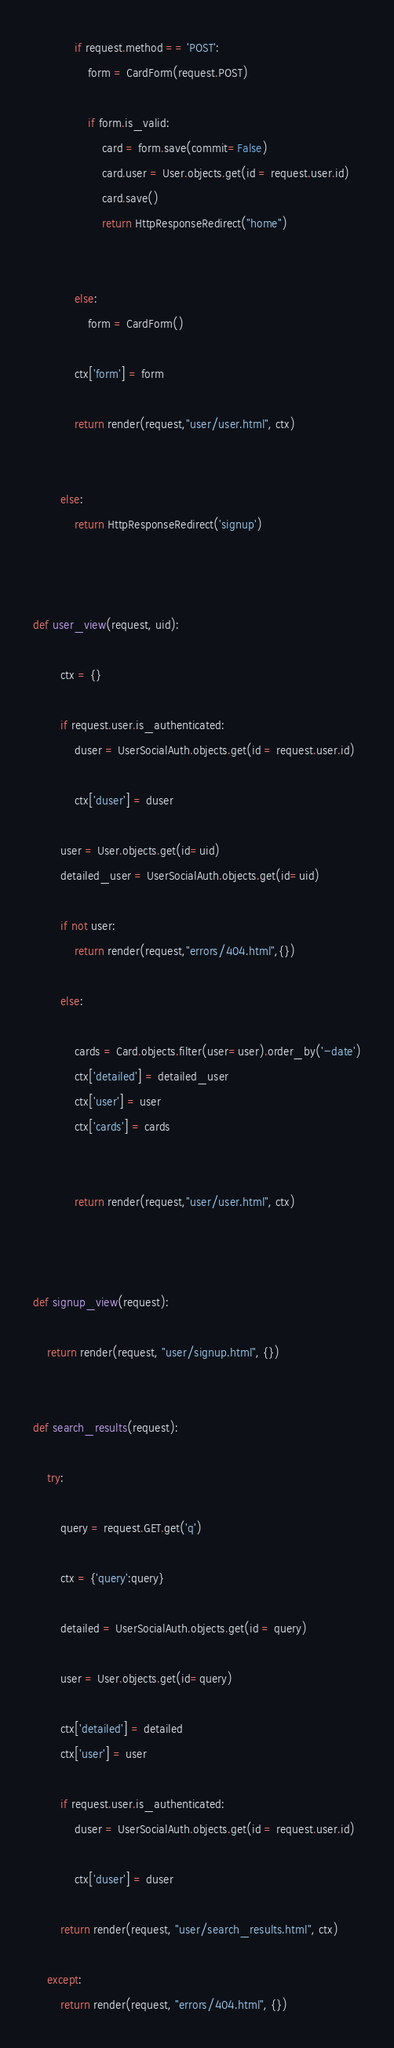<code> <loc_0><loc_0><loc_500><loc_500><_Python_>


            if request.method == 'POST':
                form = CardForm(request.POST)

                if form.is_valid:
                    card = form.save(commit=False)
                    card.user = User.objects.get(id = request.user.id)
                    card.save()
                    return HttpResponseRedirect("home")


            else:
                form = CardForm()

            ctx['form'] = form

            return render(request,"user/user.html", ctx)


        else:
            return HttpResponseRedirect('signup')



def user_view(request, uid):

        ctx = {}

        if request.user.is_authenticated:
            duser = UserSocialAuth.objects.get(id = request.user.id)

            ctx['duser'] = duser

        user = User.objects.get(id=uid)
        detailed_user = UserSocialAuth.objects.get(id=uid)

        if not user:
            return render(request,"errors/404.html",{})

        else:

            cards = Card.objects.filter(user=user).order_by('-date')
            ctx['detailed'] = detailed_user
            ctx['user'] = user
            ctx['cards'] = cards


            return render(request,"user/user.html", ctx)



def signup_view(request):

    return render(request, "user/signup.html", {})


def search_results(request):

    try:

        query = request.GET.get('q')

        ctx = {'query':query}

        detailed = UserSocialAuth.objects.get(id = query)

        user = User.objects.get(id=query)

        ctx['detailed'] = detailed
        ctx['user'] = user

        if request.user.is_authenticated:
            duser = UserSocialAuth.objects.get(id = request.user.id)

            ctx['duser'] = duser

        return render(request, "user/search_results.html", ctx)

    except:
        return render(request, "errors/404.html", {})
</code> 